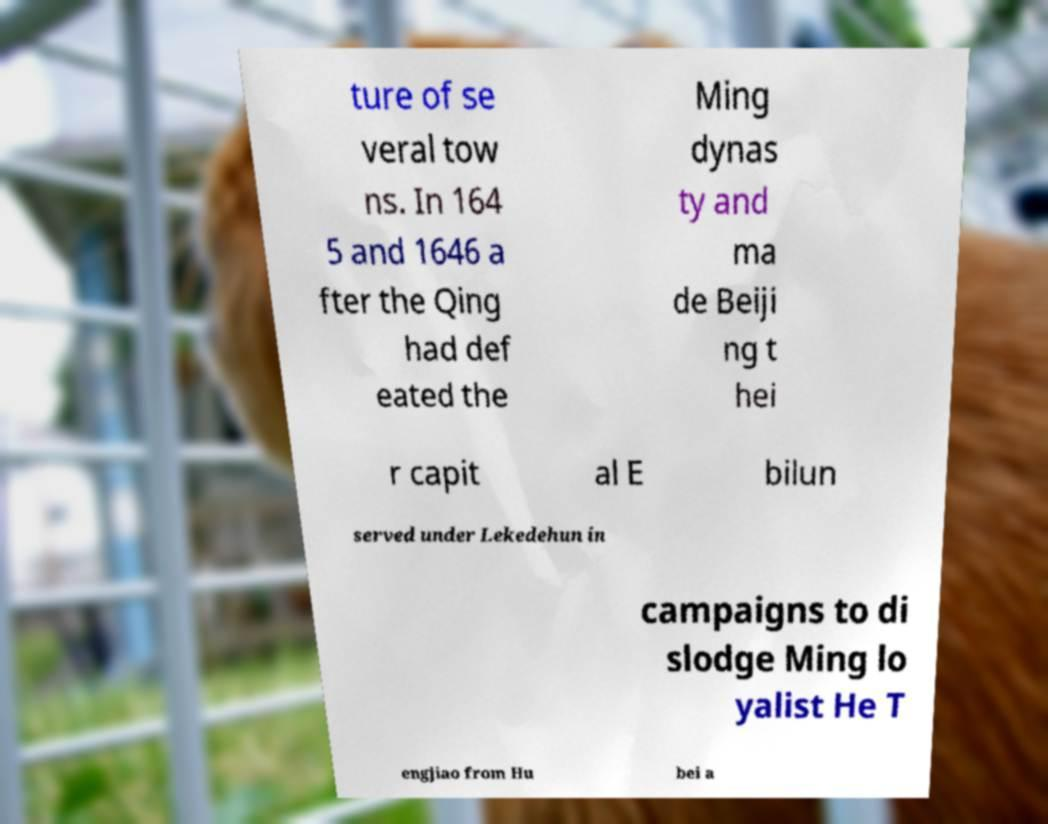There's text embedded in this image that I need extracted. Can you transcribe it verbatim? ture of se veral tow ns. In 164 5 and 1646 a fter the Qing had def eated the Ming dynas ty and ma de Beiji ng t hei r capit al E bilun served under Lekedehun in campaigns to di slodge Ming lo yalist He T engjiao from Hu bei a 